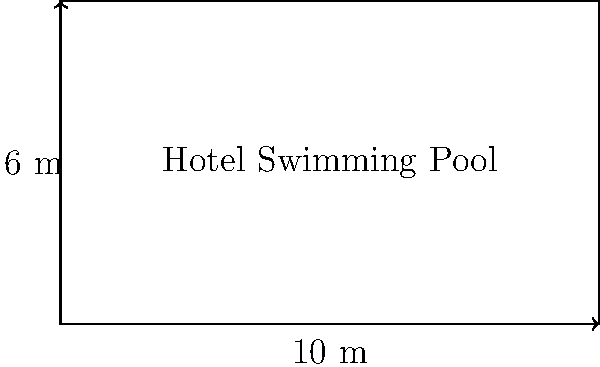During your stay at a beachfront hotel in Exmouth, you decide to measure the perimeter of the rectangular swimming pool for your travel blog. The pool measures 10 meters in length and 6 meters in width. Calculate the perimeter of the swimming pool. To calculate the perimeter of a rectangular swimming pool, we need to add up the lengths of all four sides. Let's break it down step-by-step:

1. Identify the given dimensions:
   Length (L) = 10 meters
   Width (W) = 6 meters

2. Recall the formula for the perimeter of a rectangle:
   Perimeter = 2L + 2W

3. Substitute the values into the formula:
   Perimeter = 2(10 m) + 2(6 m)

4. Simplify:
   Perimeter = 20 m + 12 m

5. Calculate the final result:
   Perimeter = 32 m

Therefore, the perimeter of the hotel swimming pool in Exmouth is 32 meters.
Answer: 32 m 